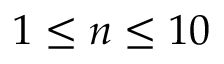<formula> <loc_0><loc_0><loc_500><loc_500>1 \leq n \leq 1 0</formula> 